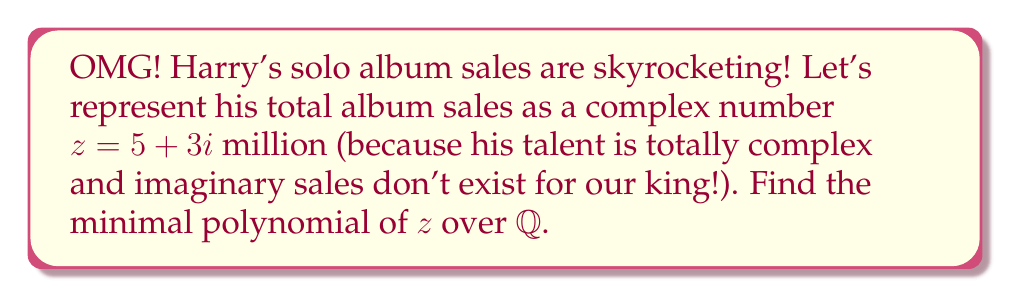What is the answer to this math problem? Let's approach this step-by-step:

1) The minimal polynomial of $z$ over $\mathbb{Q}$ is the monic polynomial of least degree with rational coefficients that has $z$ as a root.

2) We know that $z = 5 + 3i$. The conjugate of $z$ is $\bar{z} = 5 - 3i$.

3) The minimal polynomial will have both $z$ and $\bar{z}$ as roots (because its coefficients are rational).

4) Therefore, the minimal polynomial will be of the form:

   $$(x - z)(x - \bar{z}) = 0$$

5) Let's expand this:
   
   $$(x - (5+3i))(x - (5-3i)) = 0$$
   
   $$(x - 5 - 3i)(x - 5 + 3i) = 0$$
   
   $$x^2 - 5x + 3ix - 5x + 25 - 15i + 3ix - 15i + 9i^2 = 0$$
   
   $$x^2 - 10x + 25 + 9(-1) = 0$$ (since $i^2 = -1$)
   
   $$x^2 - 10x + 16 = 0$$

6) This is a monic quadratic polynomial with rational coefficients, and it has $z$ as a root.

7) No linear polynomial with rational coefficients could have $z$ as a root, so this is indeed the minimal polynomial.
Answer: $x^2 - 10x + 16$ 